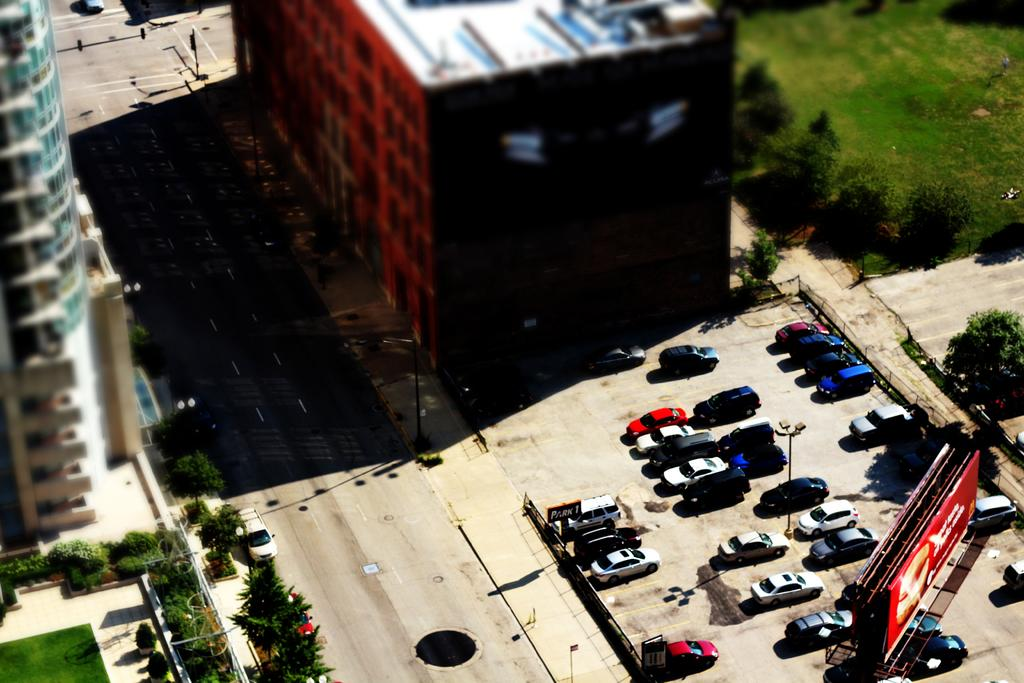What type of view is provided in the image? The image is a top view of a place. What structures can be seen in the image? There are buildings in the image. What type of vegetation is present in the image? There are trees and plants in the image. What type of animals can be seen in the image? There are cats in the image. What object is present in the image that can be used for displaying information? There is a board in the image, and a poster is attached to the side of the board. What type of pleasure can be seen being experienced by the trees in the image? There is no indication of pleasure being experienced by the trees in the image, as trees do not have the ability to experience pleasure. 